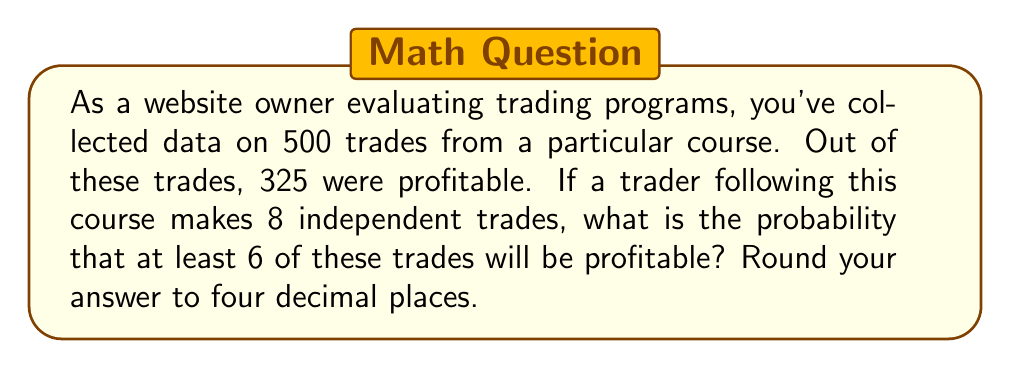Provide a solution to this math problem. To solve this problem, we'll use the binomial probability distribution.

1. First, let's identify our parameters:
   - $n$ (number of trials) = 8 trades
   - $p$ (probability of success) = 325/500 = 0.65
   - $q$ (probability of failure) = 1 - p = 0.35
   - We want the probability of at least 6 successes, so we'll calculate P(X ≥ 6)

2. The binomial probability formula is:

   $$P(X = k) = \binom{n}{k} p^k q^{n-k}$$

3. We need to calculate P(X = 6) + P(X = 7) + P(X = 8):

   $$P(X \geq 6) = \binom{8}{6} (0.65)^6 (0.35)^2 + \binom{8}{7} (0.65)^7 (0.35)^1 + \binom{8}{8} (0.65)^8 (0.35)^0$$

4. Let's calculate each term:

   $$\binom{8}{6} (0.65)^6 (0.35)^2 = 28 \times 0.075418 \times 0.1225 = 0.2589$$
   $$\binom{8}{7} (0.65)^7 (0.35)^1 = 8 \times 0.116027 \times 0.35 = 0.3249$$
   $$\binom{8}{8} (0.65)^8 (0.35)^0 = 1 \times 0.1785 \times 1 = 0.1785$$

5. Sum up the probabilities:

   $$P(X \geq 6) = 0.2589 + 0.3249 + 0.1785 = 0.7623$$

6. Rounding to four decimal places: 0.7623
Answer: 0.7623 